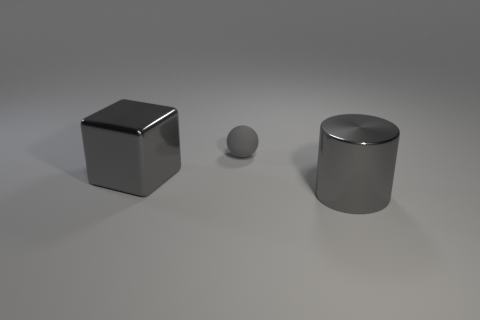How do you think the lighting is affecting the appearance of these objects? The lighting creates a soft shadow and subtle reflections on the objects, enhancing their three-dimensional form and metallic texture, and conveying a calm, balanced composition. 